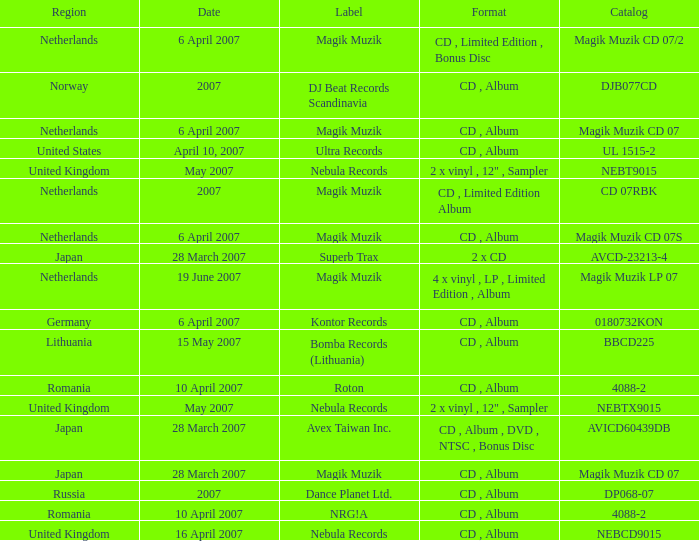Which label released the catalog Magik Muzik CD 07 on 28 March 2007? Magik Muzik. 